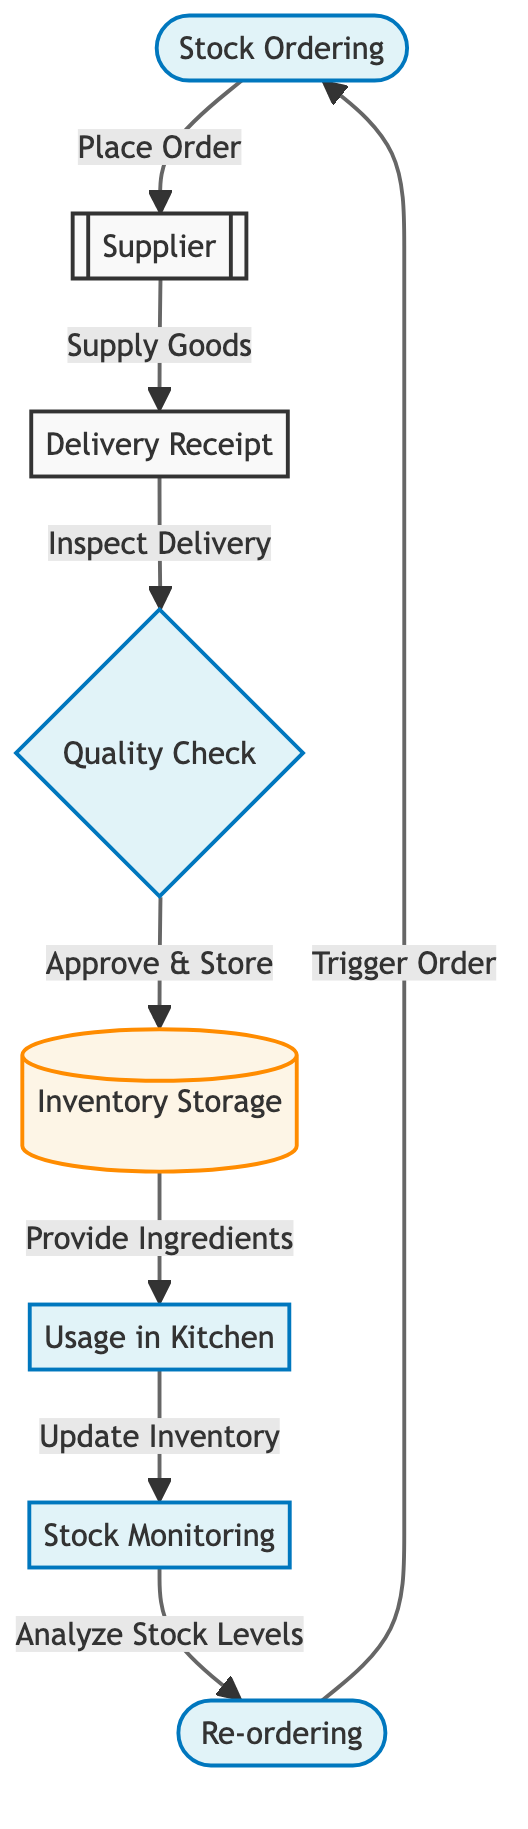What is the first step in the inventory management cycle? The first step in the inventory management cycle, as indicated in the diagram, is "Stock Ordering." This is the initial action taken to start the inventory process.
Answer: Stock Ordering How many processes are involved in the diagram? Looking at the diagram, we identify seven processes, which include Stock Ordering, Quality Check, Usage in Kitchen, Stock Monitoring, and Re-ordering as well as Delivery Receipt and Inventory Storage.
Answer: Seven What does the "Quality Check" node connect to? In the diagram, the "Quality Check" node connects to the "Inventory Storage" node. After quality assurance, the goods are moved to the storage area.
Answer: Inventory Storage What action follows "Stock Monitoring"? According to the flow of the diagram, the action that follows "Stock Monitoring" is "Re-ordering." Once stock levels are analyzed, new orders are triggered.
Answer: Re-ordering How are goods delivered from the supplier? The goods are delivered from the supplier through the node labeled "Supply Goods," which connects the supplier to the "Delivery Receipt" node in the diagram.
Answer: Supply Goods How does the process of inventory usage begin? The process of inventory usage begins from the "Inventory Storage" node, where ingredients are taken to be used in the kitchen. It is the direct link from inventory storage to usage.
Answer: Inventory Storage Which node assesses stock levels? The node dedicated to assessing stock levels is labeled "Stock Monitoring." This node plays a vital role in evaluating the current inventory status.
Answer: Stock Monitoring What indicates the completion of the inventory cycle? The inventory cycle is indicated to be complete when "Re-ordering" triggers a new "Stock Ordering" action, creating a loop in the cycle.
Answer: Stock Ordering 